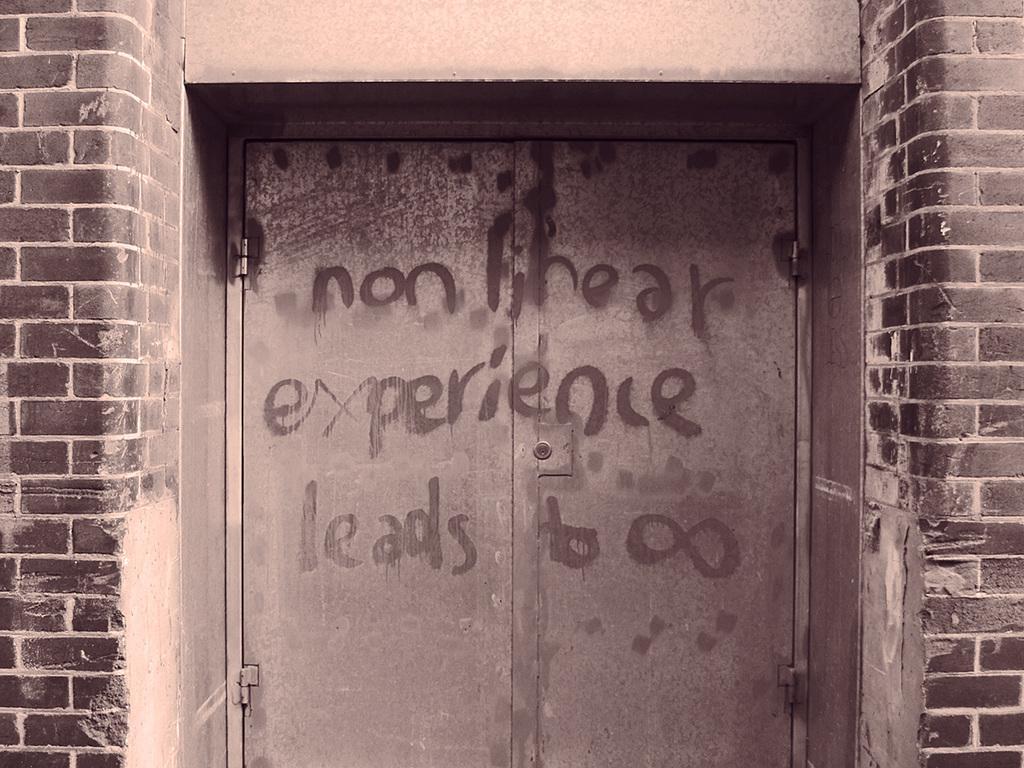How would you summarize this image in a sentence or two? In this image we can see a door with some text on it and walls. 